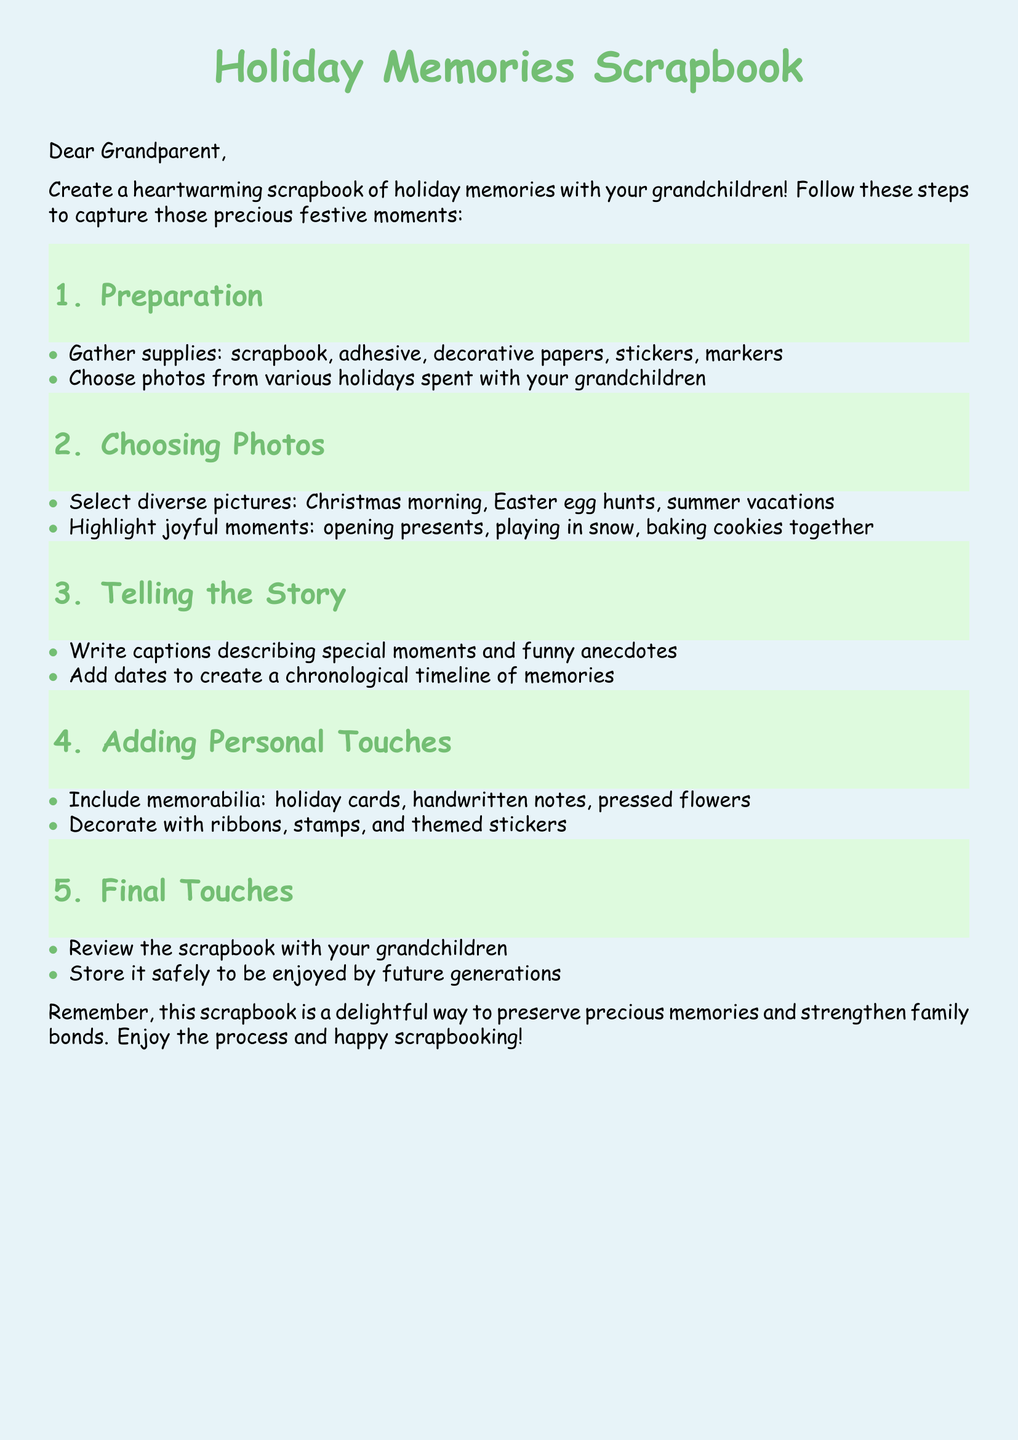What is the title of the document? The title is prominently displayed at the beginning of the document, titled "Holiday Memories Scrapbook."
Answer: Holiday Memories Scrapbook How many sections are in the scrapbook guide? The document lists five distinct sections that guide the scrapbook creation process.
Answer: 5 What is the first step in creating the scrapbook? The first step outlined involves gathering necessary supplies to begin the scrapbook project.
Answer: Preparation What type of photos should be selected for the scrapbook? The document specifies that diverse pictures from various holidays spent with grandchildren should be chosen.
Answer: Diverse pictures What should be included to add personal touches? The guide mentions adding memorabilia such as holiday cards and handwritten notes as personal touches.
Answer: Memorabilia What is suggested to be reviewed once the scrapbook is completed? The document recommends reviewing the scrapbook with grandchildren as a final touch of the project.
Answer: Scrapbook What decorative supplies are mentioned for the scrapbook? Various decorative elements such as ribbons, stamps, and themed stickers are listed as supplies for decoration.
Answer: Ribbons, stamps, themed stickers What is the main purpose of the scrapbook according to the document? The document indicates that the primary purpose of the scrapbook is to preserve precious memories and strengthen family bonds.
Answer: Preserve precious memories What does the document emphasize about the scrapbook creation process? The end of the document encourages enjoyment of the scrapbook creation process, indicating it's a joyful activity.
Answer: Enjoy the process 